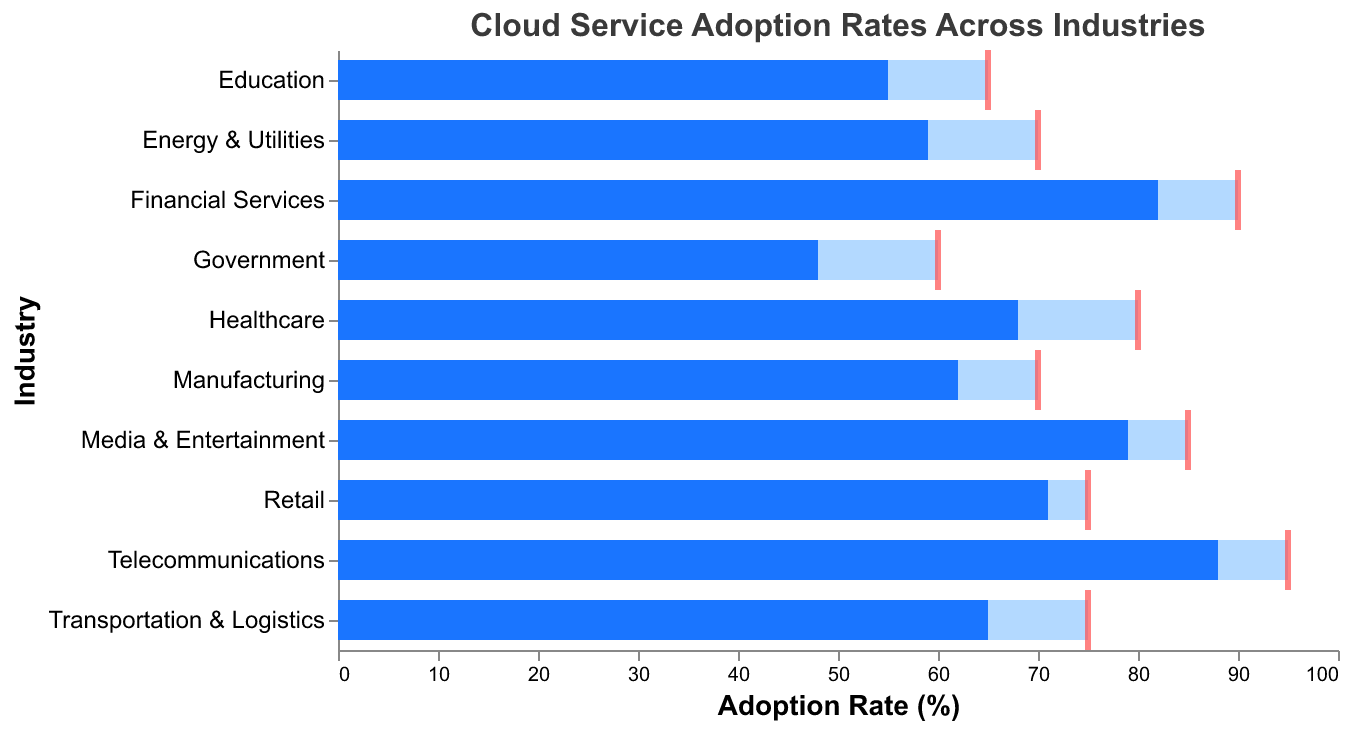What's the title of the chart? The title is located at the top and reads, "Cloud Service Adoption Rates Across Industries".
Answer: Cloud Service Adoption Rates Across Industries How many industries are represented in the chart? Count the number of unique industry names listed on the y-axis.
Answer: 10 Which industry has the highest actual cloud service adoption rate? Look at the "Actual Usage (%)" bars to find the one with the highest value. Telecommunications has the highest actual usage.
Answer: Telecommunications Which industry has the lowest actual cloud service adoption rate? Look at the "Actual Usage (%)" bars to find the one with the lowest value. Government has the lowest actual usage.
Answer: Government How many industries have an actual usage rate above 70%? Count the number of "Actual Usage (%)" bars with values greater than 70. Financial Services, Retail, Media & Entertainment, and Telecommunications are the ones with actual usage above 70%.
Answer: 4 What is the difference between actual and target usage for the healthcare industry? Subtract the actual usage from the target usage for healthcare: 80 - 68.
Answer: 12 Which industry is closest to meeting its target usage? Compare the differences between target and actual usages for each industry. Retail has the smallest difference (75 - 71).
Answer: Retail What is the average actual cloud service adoption rate across all industries? Sum all actual usage percentages and divide by the number of industries (68 + 82 + 71 + 62 + 55 + 48 + 79 + 88 + 65 + 59) / 10.
Answer: 67.7 Which industry has the largest gap between actual and target usage? Calculate the differences for each industry and determine the largest gap. Government has the largest gap (60 - 48).
Answer: Government Which industries have actual usage rates lower than their target usage rates? Identify the industries where actual % is less than target %. Healthcare, Financial Services, Manufacturing, Education, Government, Media & Entertainment, Telecommunications, Transportation & Logistics, Energy & Utilities.
Answer: 9 